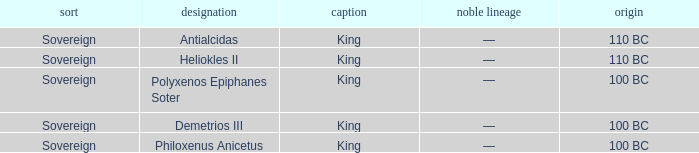When did Philoxenus Anicetus begin to hold power? 100 BC. 